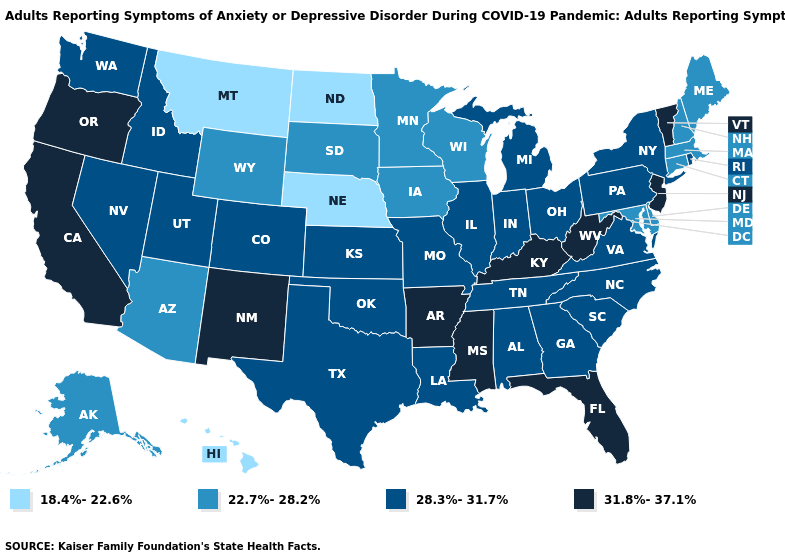Name the states that have a value in the range 18.4%-22.6%?
Quick response, please. Hawaii, Montana, Nebraska, North Dakota. What is the highest value in the USA?
Keep it brief. 31.8%-37.1%. Which states have the lowest value in the USA?
Give a very brief answer. Hawaii, Montana, Nebraska, North Dakota. Name the states that have a value in the range 31.8%-37.1%?
Answer briefly. Arkansas, California, Florida, Kentucky, Mississippi, New Jersey, New Mexico, Oregon, Vermont, West Virginia. Does Washington have the highest value in the USA?
Concise answer only. No. What is the value of Montana?
Quick response, please. 18.4%-22.6%. What is the lowest value in the USA?
Write a very short answer. 18.4%-22.6%. Name the states that have a value in the range 22.7%-28.2%?
Give a very brief answer. Alaska, Arizona, Connecticut, Delaware, Iowa, Maine, Maryland, Massachusetts, Minnesota, New Hampshire, South Dakota, Wisconsin, Wyoming. Does the map have missing data?
Concise answer only. No. Is the legend a continuous bar?
Be succinct. No. Does the first symbol in the legend represent the smallest category?
Write a very short answer. Yes. What is the highest value in the USA?
Quick response, please. 31.8%-37.1%. Among the states that border Vermont , which have the lowest value?
Quick response, please. Massachusetts, New Hampshire. Among the states that border California , which have the lowest value?
Keep it brief. Arizona. What is the value of Maryland?
Keep it brief. 22.7%-28.2%. 